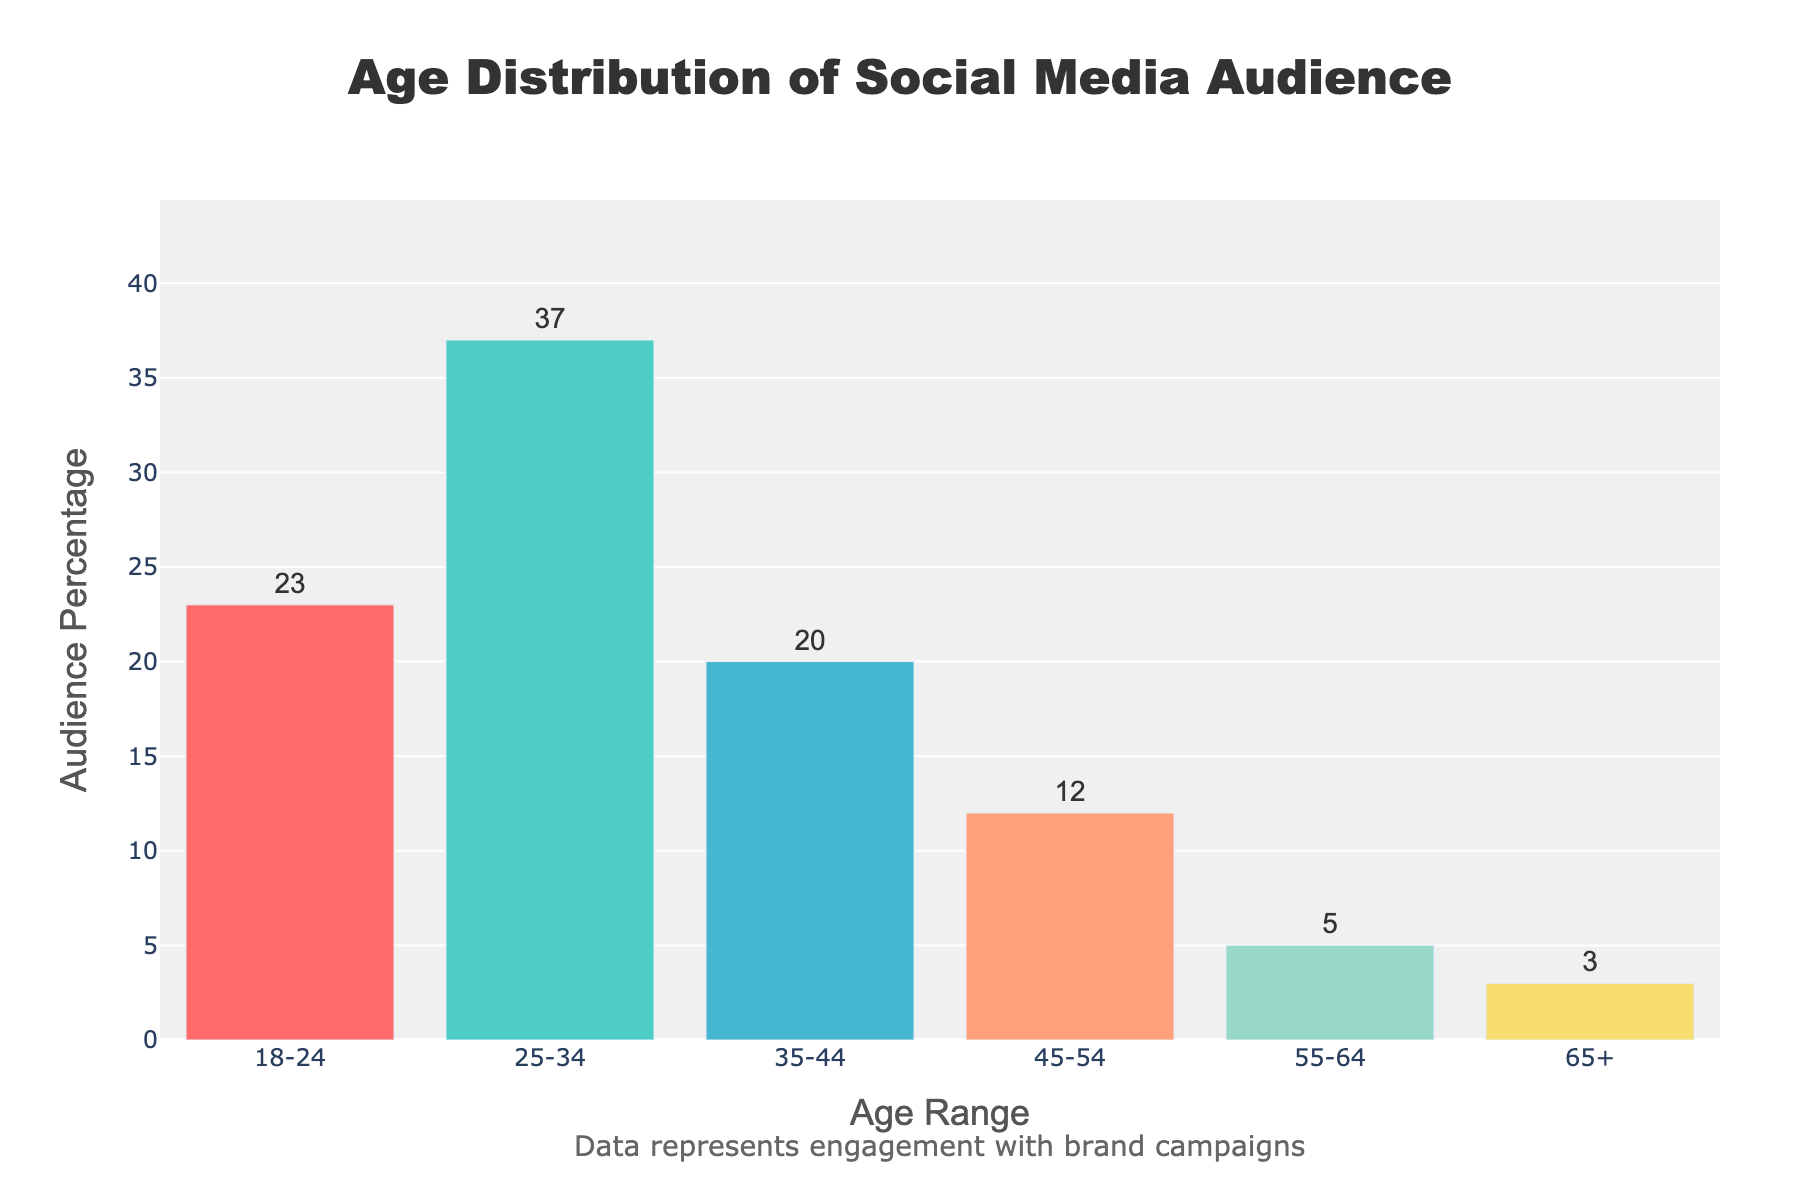What's the title of the plot? The title is prominently displayed at the top of the plot.
Answer: Age Distribution of Social Media Audience Which age range has the highest audience percentage? By looking at the bars, the highest bar represents the age range with the greatest audience percentage.
Answer: 25-34 How many age ranges are presented in the plot? Counting the distinct age categories shown on the x-axis will give the number of age ranges.
Answer: 6 What is the percentage of the audience in the 45-54 age range? The y-axis provides the percentage for each age range; check the one labeled 45-54.
Answer: 12% What are the total audience percentages of the age ranges 35-44 and 45-54 combined? Add the percentages for the 35-44 and 45-54 age ranges (20% + 12%).
Answer: 32% What is the difference in audience percentage between the age ranges 18-24 and 55-64? Subtract the percentage of the 55-64 age range from that of the 18-24 age range (23% - 5%).
Answer: 18% Which age range has the lowest engagement percentage? Identify the bar with the smallest height to determine the age range with the lowest engagement.
Answer: 65+ Is the audience larger in the age range 25-34 than in the age range 35-44? Compare the heights of the bars representing the 25-34 and 35-44 age ranges.
Answer: Yes What's the average audience percentage across all age ranges? To find the average, sum all the percentages and divide by the number of age ranges: (23 + 37 + 20 + 12 + 5 + 3) / 6.
Answer: 16.67% How does the audience percentage of the 18-24 age range compare to that of the 65+ age range? Compare the percentages directly; the 18-24 age range has a higher percentage than the 65+ age range.
Answer: 18-24 is higher 